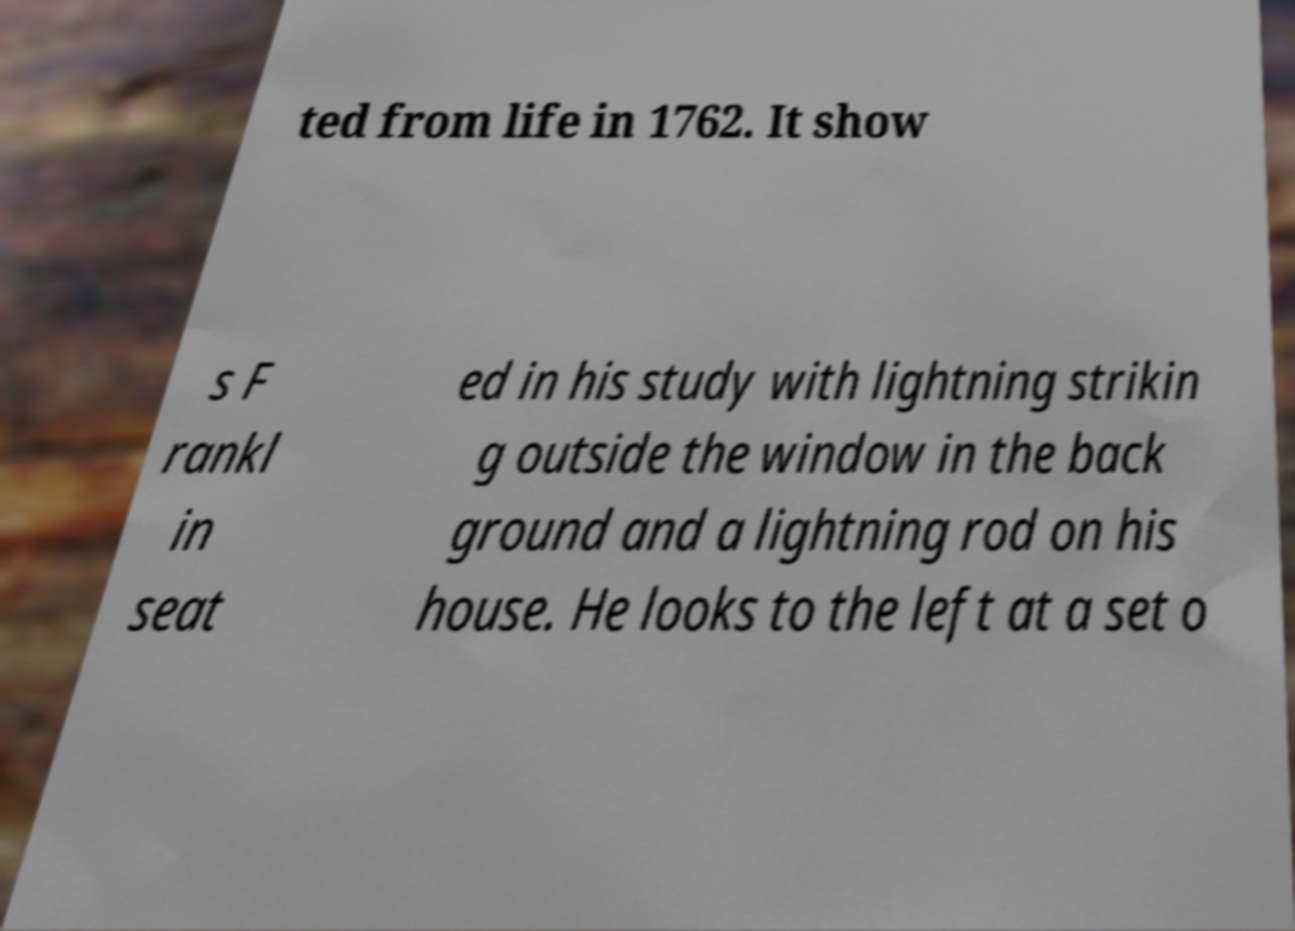For documentation purposes, I need the text within this image transcribed. Could you provide that? ted from life in 1762. It show s F rankl in seat ed in his study with lightning strikin g outside the window in the back ground and a lightning rod on his house. He looks to the left at a set o 